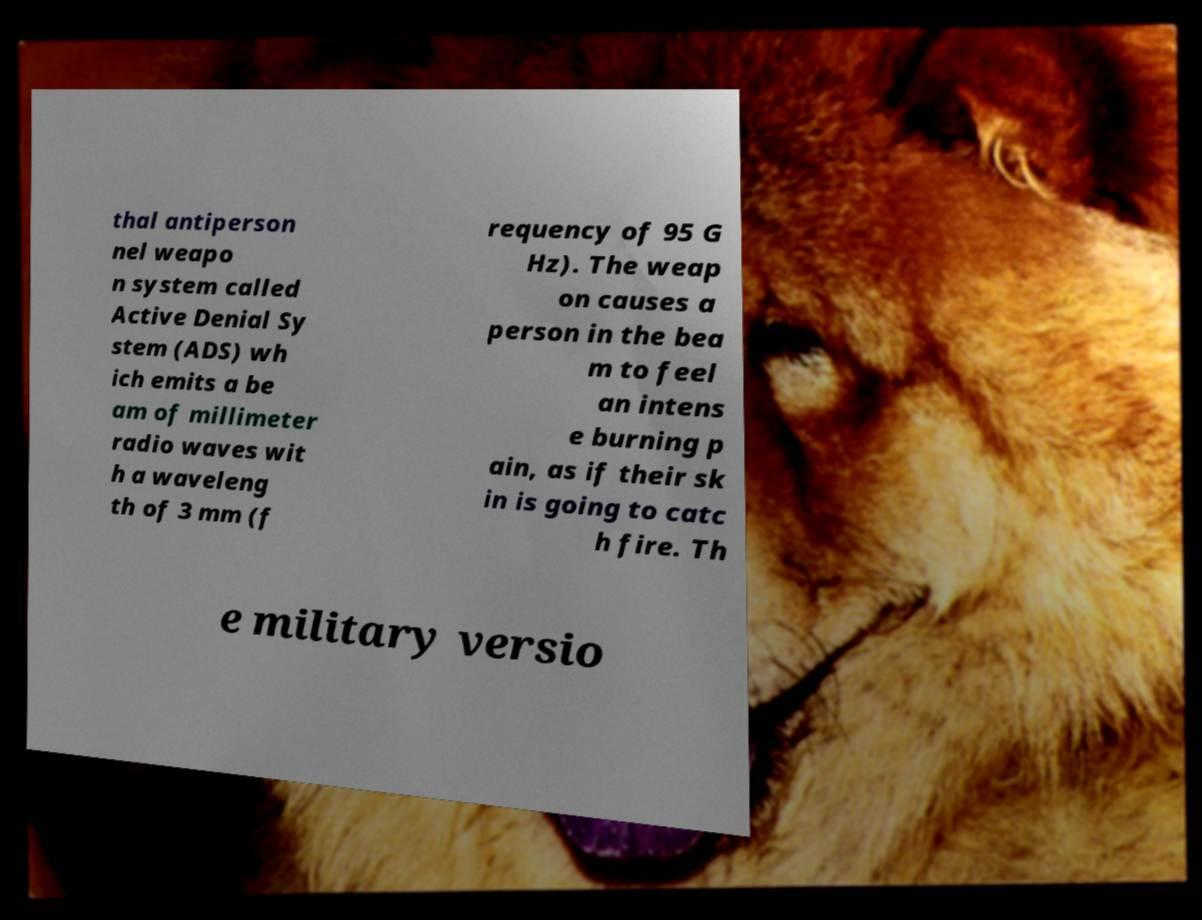What messages or text are displayed in this image? I need them in a readable, typed format. thal antiperson nel weapo n system called Active Denial Sy stem (ADS) wh ich emits a be am of millimeter radio waves wit h a waveleng th of 3 mm (f requency of 95 G Hz). The weap on causes a person in the bea m to feel an intens e burning p ain, as if their sk in is going to catc h fire. Th e military versio 